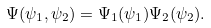Convert formula to latex. <formula><loc_0><loc_0><loc_500><loc_500>\Psi ( \psi _ { 1 } , \psi _ { 2 } ) = \Psi _ { 1 } ( \psi _ { 1 } ) \Psi _ { 2 } ( \psi _ { 2 } ) .</formula> 